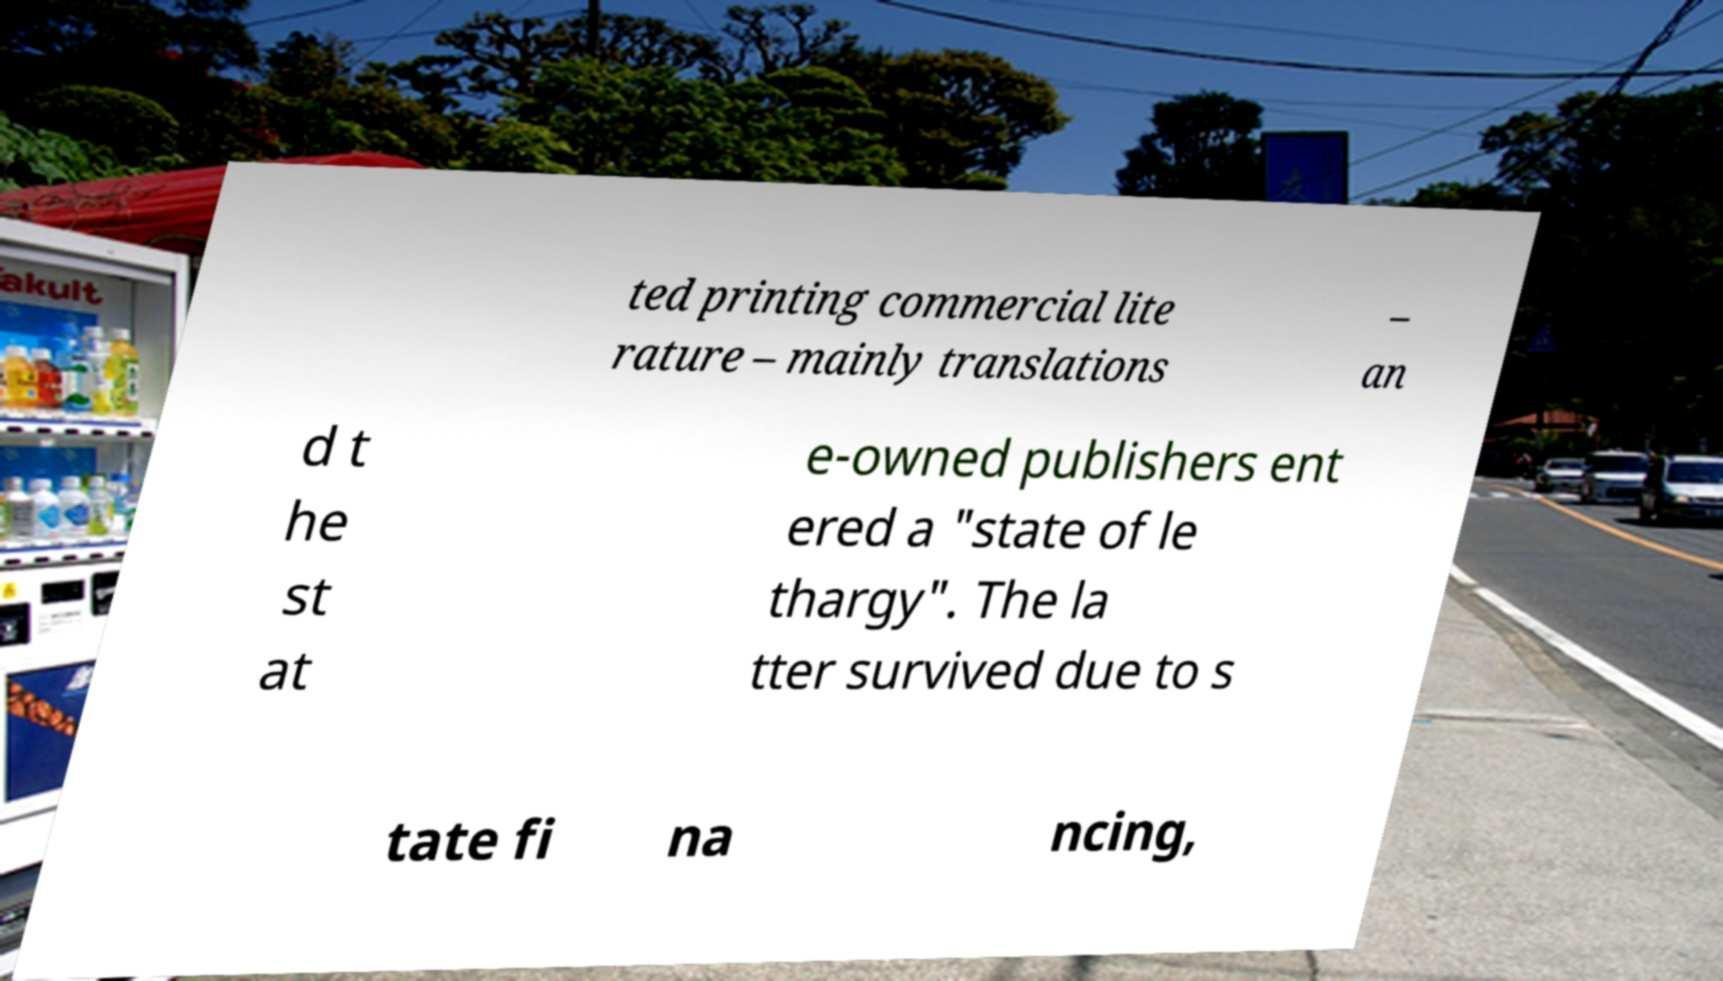Could you extract and type out the text from this image? ted printing commercial lite rature – mainly translations – an d t he st at e-owned publishers ent ered a "state of le thargy". The la tter survived due to s tate fi na ncing, 